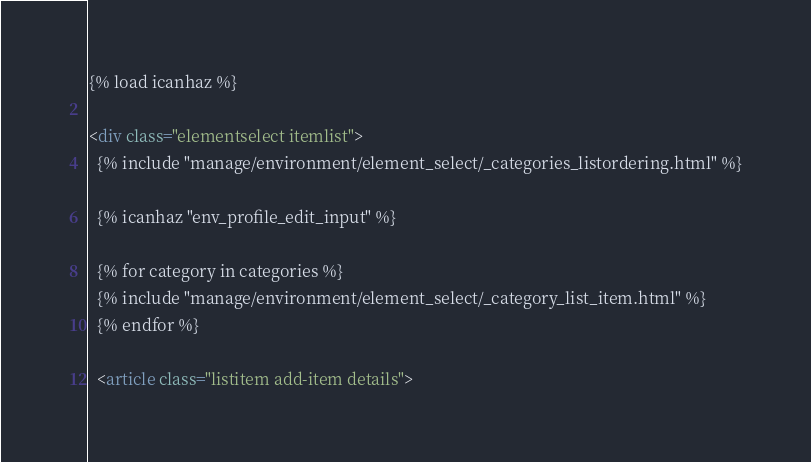Convert code to text. <code><loc_0><loc_0><loc_500><loc_500><_HTML_>{% load icanhaz %}

<div class="elementselect itemlist">
  {% include "manage/environment/element_select/_categories_listordering.html" %}

  {% icanhaz "env_profile_edit_input" %}

  {% for category in categories %}
  {% include "manage/environment/element_select/_category_list_item.html" %}
  {% endfor %}

  <article class="listitem add-item details"></code> 